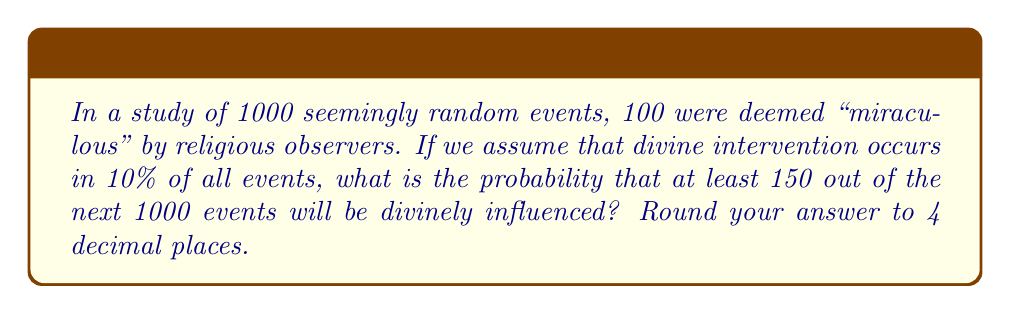Can you answer this question? To solve this problem, we'll use the binomial probability distribution, assuming divine intervention as a "success" and no intervention as a "failure."

1) Let $X$ be the number of divinely influenced events in 1000 trials.
2) $X$ follows a binomial distribution with $n = 1000$ and $p = 0.10$
3) We want to find $P(X \geq 150)$

The probability mass function for a binomial distribution is:

$$ P(X = k) = \binom{n}{k} p^k (1-p)^{n-k} $$

However, calculating $P(X \geq 150)$ directly would be time-consuming. Instead, we can use the normal approximation to the binomial distribution, which is valid when $np > 5$ and $n(1-p) > 5$. In this case:

$np = 1000 * 0.10 = 100 > 5$
$n(1-p) = 1000 * 0.90 = 900 > 5$

So we can use the normal approximation.

4) For a normal approximation:
   Mean $\mu = np = 1000 * 0.10 = 100$
   Standard deviation $\sigma = \sqrt{np(1-p)} = \sqrt{1000 * 0.10 * 0.90} = 9.487$

5) We need to find $P(X \geq 150)$, which is equivalent to $P(X > 149.5)$ with continuity correction.

6) Convert to z-score:
   $z = \frac{149.5 - 100}{9.487} = 5.218$

7) Use a standard normal table or calculator to find $P(Z > 5.218)$

8) $P(X \geq 150) = P(Z > 5.218) = 1 - P(Z < 5.218) \approx 1 - 0.9999999$
Answer: $8.9 \times 10^{-8}$ or $0.0000$ 